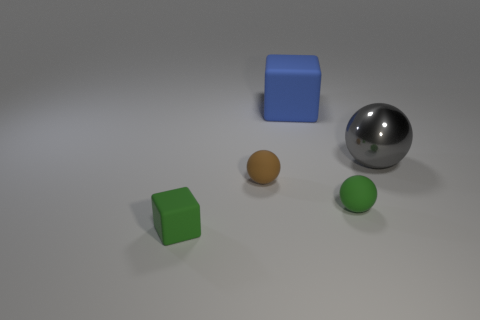There is a brown rubber thing; is it the same shape as the large blue thing that is to the left of the metal ball?
Offer a terse response. No. What is the color of the big block that is the same material as the green ball?
Offer a terse response. Blue. The large ball is what color?
Make the answer very short. Gray. Does the tiny brown sphere have the same material as the block in front of the large blue matte thing?
Offer a terse response. Yes. How many things are both behind the green sphere and left of the big matte object?
Provide a succinct answer. 1. There is a blue thing that is the same size as the gray metal object; what is its shape?
Your answer should be very brief. Cube. There is a object that is to the right of the tiny rubber ball to the right of the large blue matte cube; is there a large metallic sphere behind it?
Your answer should be compact. No. There is a big matte thing; is its color the same as the rubber block in front of the gray metallic ball?
Keep it short and to the point. No. How many shiny objects have the same color as the big ball?
Give a very brief answer. 0. What size is the green thing that is to the right of the matte block that is behind the gray metal sphere?
Provide a short and direct response. Small. 